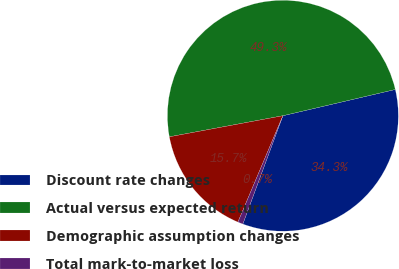Convert chart. <chart><loc_0><loc_0><loc_500><loc_500><pie_chart><fcel>Discount rate changes<fcel>Actual versus expected return<fcel>Demographic assumption changes<fcel>Total mark-to-market loss<nl><fcel>34.29%<fcel>49.27%<fcel>15.71%<fcel>0.73%<nl></chart> 